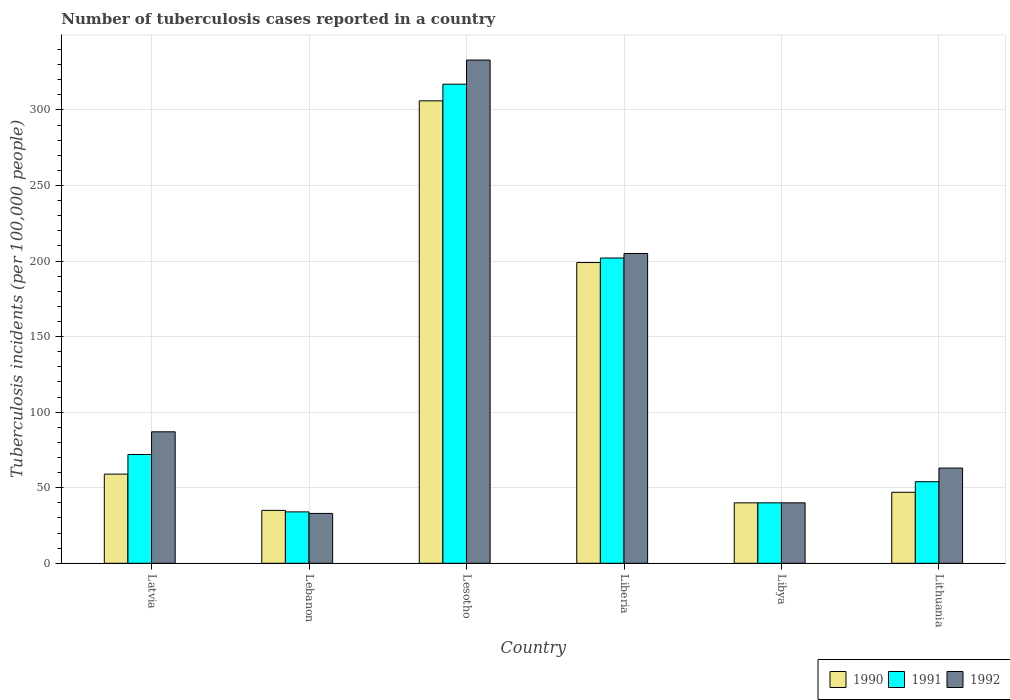How many groups of bars are there?
Your response must be concise. 6. Are the number of bars per tick equal to the number of legend labels?
Your answer should be compact. Yes. How many bars are there on the 6th tick from the right?
Provide a succinct answer. 3. What is the label of the 6th group of bars from the left?
Ensure brevity in your answer.  Lithuania. In how many cases, is the number of bars for a given country not equal to the number of legend labels?
Make the answer very short. 0. What is the number of tuberculosis cases reported in in 1990 in Lesotho?
Provide a succinct answer. 306. Across all countries, what is the maximum number of tuberculosis cases reported in in 1990?
Provide a succinct answer. 306. In which country was the number of tuberculosis cases reported in in 1991 maximum?
Ensure brevity in your answer.  Lesotho. In which country was the number of tuberculosis cases reported in in 1990 minimum?
Make the answer very short. Lebanon. What is the total number of tuberculosis cases reported in in 1990 in the graph?
Give a very brief answer. 686. What is the difference between the number of tuberculosis cases reported in in 1990 in Latvia and that in Lesotho?
Provide a short and direct response. -247. What is the difference between the number of tuberculosis cases reported in in 1991 in Liberia and the number of tuberculosis cases reported in in 1990 in Lithuania?
Provide a short and direct response. 155. What is the average number of tuberculosis cases reported in in 1990 per country?
Offer a terse response. 114.33. In how many countries, is the number of tuberculosis cases reported in in 1990 greater than 320?
Your answer should be very brief. 0. What is the ratio of the number of tuberculosis cases reported in in 1991 in Latvia to that in Lesotho?
Make the answer very short. 0.23. What is the difference between the highest and the second highest number of tuberculosis cases reported in in 1990?
Give a very brief answer. 247. What is the difference between the highest and the lowest number of tuberculosis cases reported in in 1992?
Make the answer very short. 300. In how many countries, is the number of tuberculosis cases reported in in 1990 greater than the average number of tuberculosis cases reported in in 1990 taken over all countries?
Offer a very short reply. 2. What does the 3rd bar from the left in Lithuania represents?
Keep it short and to the point. 1992. What does the 2nd bar from the right in Libya represents?
Provide a succinct answer. 1991. Is it the case that in every country, the sum of the number of tuberculosis cases reported in in 1990 and number of tuberculosis cases reported in in 1991 is greater than the number of tuberculosis cases reported in in 1992?
Make the answer very short. Yes. How many bars are there?
Keep it short and to the point. 18. Are all the bars in the graph horizontal?
Offer a terse response. No. Are the values on the major ticks of Y-axis written in scientific E-notation?
Provide a succinct answer. No. Does the graph contain any zero values?
Provide a succinct answer. No. Does the graph contain grids?
Offer a terse response. Yes. How many legend labels are there?
Offer a terse response. 3. How are the legend labels stacked?
Offer a terse response. Horizontal. What is the title of the graph?
Your answer should be compact. Number of tuberculosis cases reported in a country. What is the label or title of the Y-axis?
Make the answer very short. Tuberculosis incidents (per 100,0 people). What is the Tuberculosis incidents (per 100,000 people) in 1991 in Latvia?
Your response must be concise. 72. What is the Tuberculosis incidents (per 100,000 people) of 1991 in Lebanon?
Give a very brief answer. 34. What is the Tuberculosis incidents (per 100,000 people) in 1990 in Lesotho?
Offer a terse response. 306. What is the Tuberculosis incidents (per 100,000 people) of 1991 in Lesotho?
Give a very brief answer. 317. What is the Tuberculosis incidents (per 100,000 people) of 1992 in Lesotho?
Give a very brief answer. 333. What is the Tuberculosis incidents (per 100,000 people) in 1990 in Liberia?
Provide a succinct answer. 199. What is the Tuberculosis incidents (per 100,000 people) in 1991 in Liberia?
Provide a succinct answer. 202. What is the Tuberculosis incidents (per 100,000 people) in 1992 in Liberia?
Make the answer very short. 205. What is the Tuberculosis incidents (per 100,000 people) of 1990 in Libya?
Give a very brief answer. 40. What is the Tuberculosis incidents (per 100,000 people) of 1991 in Libya?
Ensure brevity in your answer.  40. What is the Tuberculosis incidents (per 100,000 people) in 1992 in Libya?
Ensure brevity in your answer.  40. What is the Tuberculosis incidents (per 100,000 people) of 1991 in Lithuania?
Provide a short and direct response. 54. What is the Tuberculosis incidents (per 100,000 people) of 1992 in Lithuania?
Keep it short and to the point. 63. Across all countries, what is the maximum Tuberculosis incidents (per 100,000 people) in 1990?
Provide a short and direct response. 306. Across all countries, what is the maximum Tuberculosis incidents (per 100,000 people) of 1991?
Your answer should be very brief. 317. Across all countries, what is the maximum Tuberculosis incidents (per 100,000 people) in 1992?
Your answer should be very brief. 333. What is the total Tuberculosis incidents (per 100,000 people) in 1990 in the graph?
Provide a succinct answer. 686. What is the total Tuberculosis incidents (per 100,000 people) of 1991 in the graph?
Your answer should be very brief. 719. What is the total Tuberculosis incidents (per 100,000 people) of 1992 in the graph?
Offer a very short reply. 761. What is the difference between the Tuberculosis incidents (per 100,000 people) of 1990 in Latvia and that in Lebanon?
Provide a short and direct response. 24. What is the difference between the Tuberculosis incidents (per 100,000 people) of 1991 in Latvia and that in Lebanon?
Your answer should be compact. 38. What is the difference between the Tuberculosis incidents (per 100,000 people) of 1992 in Latvia and that in Lebanon?
Provide a succinct answer. 54. What is the difference between the Tuberculosis incidents (per 100,000 people) of 1990 in Latvia and that in Lesotho?
Your answer should be very brief. -247. What is the difference between the Tuberculosis incidents (per 100,000 people) in 1991 in Latvia and that in Lesotho?
Keep it short and to the point. -245. What is the difference between the Tuberculosis incidents (per 100,000 people) in 1992 in Latvia and that in Lesotho?
Ensure brevity in your answer.  -246. What is the difference between the Tuberculosis incidents (per 100,000 people) in 1990 in Latvia and that in Liberia?
Ensure brevity in your answer.  -140. What is the difference between the Tuberculosis incidents (per 100,000 people) of 1991 in Latvia and that in Liberia?
Make the answer very short. -130. What is the difference between the Tuberculosis incidents (per 100,000 people) of 1992 in Latvia and that in Liberia?
Your response must be concise. -118. What is the difference between the Tuberculosis incidents (per 100,000 people) in 1991 in Latvia and that in Libya?
Provide a short and direct response. 32. What is the difference between the Tuberculosis incidents (per 100,000 people) in 1992 in Latvia and that in Libya?
Your response must be concise. 47. What is the difference between the Tuberculosis incidents (per 100,000 people) of 1990 in Latvia and that in Lithuania?
Provide a short and direct response. 12. What is the difference between the Tuberculosis incidents (per 100,000 people) of 1991 in Latvia and that in Lithuania?
Your answer should be compact. 18. What is the difference between the Tuberculosis incidents (per 100,000 people) in 1992 in Latvia and that in Lithuania?
Make the answer very short. 24. What is the difference between the Tuberculosis incidents (per 100,000 people) in 1990 in Lebanon and that in Lesotho?
Make the answer very short. -271. What is the difference between the Tuberculosis incidents (per 100,000 people) in 1991 in Lebanon and that in Lesotho?
Give a very brief answer. -283. What is the difference between the Tuberculosis incidents (per 100,000 people) in 1992 in Lebanon and that in Lesotho?
Offer a very short reply. -300. What is the difference between the Tuberculosis incidents (per 100,000 people) in 1990 in Lebanon and that in Liberia?
Offer a terse response. -164. What is the difference between the Tuberculosis incidents (per 100,000 people) of 1991 in Lebanon and that in Liberia?
Give a very brief answer. -168. What is the difference between the Tuberculosis incidents (per 100,000 people) in 1992 in Lebanon and that in Liberia?
Your answer should be compact. -172. What is the difference between the Tuberculosis incidents (per 100,000 people) in 1990 in Lebanon and that in Libya?
Keep it short and to the point. -5. What is the difference between the Tuberculosis incidents (per 100,000 people) in 1991 in Lebanon and that in Libya?
Keep it short and to the point. -6. What is the difference between the Tuberculosis incidents (per 100,000 people) of 1992 in Lebanon and that in Libya?
Keep it short and to the point. -7. What is the difference between the Tuberculosis incidents (per 100,000 people) in 1990 in Lebanon and that in Lithuania?
Your answer should be very brief. -12. What is the difference between the Tuberculosis incidents (per 100,000 people) in 1991 in Lebanon and that in Lithuania?
Provide a short and direct response. -20. What is the difference between the Tuberculosis incidents (per 100,000 people) in 1992 in Lebanon and that in Lithuania?
Your answer should be compact. -30. What is the difference between the Tuberculosis incidents (per 100,000 people) in 1990 in Lesotho and that in Liberia?
Offer a very short reply. 107. What is the difference between the Tuberculosis incidents (per 100,000 people) of 1991 in Lesotho and that in Liberia?
Give a very brief answer. 115. What is the difference between the Tuberculosis incidents (per 100,000 people) of 1992 in Lesotho and that in Liberia?
Ensure brevity in your answer.  128. What is the difference between the Tuberculosis incidents (per 100,000 people) in 1990 in Lesotho and that in Libya?
Ensure brevity in your answer.  266. What is the difference between the Tuberculosis incidents (per 100,000 people) in 1991 in Lesotho and that in Libya?
Your response must be concise. 277. What is the difference between the Tuberculosis incidents (per 100,000 people) of 1992 in Lesotho and that in Libya?
Your answer should be compact. 293. What is the difference between the Tuberculosis incidents (per 100,000 people) in 1990 in Lesotho and that in Lithuania?
Keep it short and to the point. 259. What is the difference between the Tuberculosis incidents (per 100,000 people) in 1991 in Lesotho and that in Lithuania?
Provide a short and direct response. 263. What is the difference between the Tuberculosis incidents (per 100,000 people) in 1992 in Lesotho and that in Lithuania?
Provide a short and direct response. 270. What is the difference between the Tuberculosis incidents (per 100,000 people) in 1990 in Liberia and that in Libya?
Ensure brevity in your answer.  159. What is the difference between the Tuberculosis incidents (per 100,000 people) of 1991 in Liberia and that in Libya?
Provide a short and direct response. 162. What is the difference between the Tuberculosis incidents (per 100,000 people) in 1992 in Liberia and that in Libya?
Offer a terse response. 165. What is the difference between the Tuberculosis incidents (per 100,000 people) in 1990 in Liberia and that in Lithuania?
Offer a very short reply. 152. What is the difference between the Tuberculosis incidents (per 100,000 people) of 1991 in Liberia and that in Lithuania?
Give a very brief answer. 148. What is the difference between the Tuberculosis incidents (per 100,000 people) of 1992 in Liberia and that in Lithuania?
Ensure brevity in your answer.  142. What is the difference between the Tuberculosis incidents (per 100,000 people) of 1990 in Libya and that in Lithuania?
Your answer should be compact. -7. What is the difference between the Tuberculosis incidents (per 100,000 people) in 1992 in Libya and that in Lithuania?
Give a very brief answer. -23. What is the difference between the Tuberculosis incidents (per 100,000 people) in 1990 in Latvia and the Tuberculosis incidents (per 100,000 people) in 1991 in Lebanon?
Offer a very short reply. 25. What is the difference between the Tuberculosis incidents (per 100,000 people) of 1990 in Latvia and the Tuberculosis incidents (per 100,000 people) of 1992 in Lebanon?
Give a very brief answer. 26. What is the difference between the Tuberculosis incidents (per 100,000 people) of 1990 in Latvia and the Tuberculosis incidents (per 100,000 people) of 1991 in Lesotho?
Provide a succinct answer. -258. What is the difference between the Tuberculosis incidents (per 100,000 people) of 1990 in Latvia and the Tuberculosis incidents (per 100,000 people) of 1992 in Lesotho?
Make the answer very short. -274. What is the difference between the Tuberculosis incidents (per 100,000 people) in 1991 in Latvia and the Tuberculosis incidents (per 100,000 people) in 1992 in Lesotho?
Your answer should be compact. -261. What is the difference between the Tuberculosis incidents (per 100,000 people) in 1990 in Latvia and the Tuberculosis incidents (per 100,000 people) in 1991 in Liberia?
Offer a terse response. -143. What is the difference between the Tuberculosis incidents (per 100,000 people) in 1990 in Latvia and the Tuberculosis incidents (per 100,000 people) in 1992 in Liberia?
Your answer should be compact. -146. What is the difference between the Tuberculosis incidents (per 100,000 people) in 1991 in Latvia and the Tuberculosis incidents (per 100,000 people) in 1992 in Liberia?
Your answer should be compact. -133. What is the difference between the Tuberculosis incidents (per 100,000 people) in 1990 in Latvia and the Tuberculosis incidents (per 100,000 people) in 1992 in Libya?
Give a very brief answer. 19. What is the difference between the Tuberculosis incidents (per 100,000 people) in 1991 in Latvia and the Tuberculosis incidents (per 100,000 people) in 1992 in Libya?
Your answer should be very brief. 32. What is the difference between the Tuberculosis incidents (per 100,000 people) of 1990 in Latvia and the Tuberculosis incidents (per 100,000 people) of 1991 in Lithuania?
Give a very brief answer. 5. What is the difference between the Tuberculosis incidents (per 100,000 people) of 1991 in Latvia and the Tuberculosis incidents (per 100,000 people) of 1992 in Lithuania?
Provide a short and direct response. 9. What is the difference between the Tuberculosis incidents (per 100,000 people) in 1990 in Lebanon and the Tuberculosis incidents (per 100,000 people) in 1991 in Lesotho?
Keep it short and to the point. -282. What is the difference between the Tuberculosis incidents (per 100,000 people) in 1990 in Lebanon and the Tuberculosis incidents (per 100,000 people) in 1992 in Lesotho?
Make the answer very short. -298. What is the difference between the Tuberculosis incidents (per 100,000 people) of 1991 in Lebanon and the Tuberculosis incidents (per 100,000 people) of 1992 in Lesotho?
Give a very brief answer. -299. What is the difference between the Tuberculosis incidents (per 100,000 people) of 1990 in Lebanon and the Tuberculosis incidents (per 100,000 people) of 1991 in Liberia?
Your answer should be very brief. -167. What is the difference between the Tuberculosis incidents (per 100,000 people) of 1990 in Lebanon and the Tuberculosis incidents (per 100,000 people) of 1992 in Liberia?
Give a very brief answer. -170. What is the difference between the Tuberculosis incidents (per 100,000 people) in 1991 in Lebanon and the Tuberculosis incidents (per 100,000 people) in 1992 in Liberia?
Your response must be concise. -171. What is the difference between the Tuberculosis incidents (per 100,000 people) of 1990 in Lebanon and the Tuberculosis incidents (per 100,000 people) of 1992 in Lithuania?
Keep it short and to the point. -28. What is the difference between the Tuberculosis incidents (per 100,000 people) in 1990 in Lesotho and the Tuberculosis incidents (per 100,000 people) in 1991 in Liberia?
Provide a succinct answer. 104. What is the difference between the Tuberculosis incidents (per 100,000 people) of 1990 in Lesotho and the Tuberculosis incidents (per 100,000 people) of 1992 in Liberia?
Your response must be concise. 101. What is the difference between the Tuberculosis incidents (per 100,000 people) of 1991 in Lesotho and the Tuberculosis incidents (per 100,000 people) of 1992 in Liberia?
Provide a succinct answer. 112. What is the difference between the Tuberculosis incidents (per 100,000 people) of 1990 in Lesotho and the Tuberculosis incidents (per 100,000 people) of 1991 in Libya?
Your response must be concise. 266. What is the difference between the Tuberculosis incidents (per 100,000 people) in 1990 in Lesotho and the Tuberculosis incidents (per 100,000 people) in 1992 in Libya?
Keep it short and to the point. 266. What is the difference between the Tuberculosis incidents (per 100,000 people) in 1991 in Lesotho and the Tuberculosis incidents (per 100,000 people) in 1992 in Libya?
Your answer should be very brief. 277. What is the difference between the Tuberculosis incidents (per 100,000 people) of 1990 in Lesotho and the Tuberculosis incidents (per 100,000 people) of 1991 in Lithuania?
Provide a short and direct response. 252. What is the difference between the Tuberculosis incidents (per 100,000 people) of 1990 in Lesotho and the Tuberculosis incidents (per 100,000 people) of 1992 in Lithuania?
Your answer should be compact. 243. What is the difference between the Tuberculosis incidents (per 100,000 people) of 1991 in Lesotho and the Tuberculosis incidents (per 100,000 people) of 1992 in Lithuania?
Keep it short and to the point. 254. What is the difference between the Tuberculosis incidents (per 100,000 people) in 1990 in Liberia and the Tuberculosis incidents (per 100,000 people) in 1991 in Libya?
Make the answer very short. 159. What is the difference between the Tuberculosis incidents (per 100,000 people) in 1990 in Liberia and the Tuberculosis incidents (per 100,000 people) in 1992 in Libya?
Make the answer very short. 159. What is the difference between the Tuberculosis incidents (per 100,000 people) of 1991 in Liberia and the Tuberculosis incidents (per 100,000 people) of 1992 in Libya?
Offer a terse response. 162. What is the difference between the Tuberculosis incidents (per 100,000 people) of 1990 in Liberia and the Tuberculosis incidents (per 100,000 people) of 1991 in Lithuania?
Your answer should be compact. 145. What is the difference between the Tuberculosis incidents (per 100,000 people) in 1990 in Liberia and the Tuberculosis incidents (per 100,000 people) in 1992 in Lithuania?
Ensure brevity in your answer.  136. What is the difference between the Tuberculosis incidents (per 100,000 people) in 1991 in Liberia and the Tuberculosis incidents (per 100,000 people) in 1992 in Lithuania?
Offer a terse response. 139. What is the average Tuberculosis incidents (per 100,000 people) of 1990 per country?
Ensure brevity in your answer.  114.33. What is the average Tuberculosis incidents (per 100,000 people) in 1991 per country?
Offer a terse response. 119.83. What is the average Tuberculosis incidents (per 100,000 people) in 1992 per country?
Offer a terse response. 126.83. What is the difference between the Tuberculosis incidents (per 100,000 people) in 1990 and Tuberculosis incidents (per 100,000 people) in 1992 in Latvia?
Ensure brevity in your answer.  -28. What is the difference between the Tuberculosis incidents (per 100,000 people) of 1991 and Tuberculosis incidents (per 100,000 people) of 1992 in Latvia?
Give a very brief answer. -15. What is the difference between the Tuberculosis incidents (per 100,000 people) of 1990 and Tuberculosis incidents (per 100,000 people) of 1992 in Lebanon?
Your answer should be very brief. 2. What is the difference between the Tuberculosis incidents (per 100,000 people) in 1990 and Tuberculosis incidents (per 100,000 people) in 1991 in Lesotho?
Ensure brevity in your answer.  -11. What is the difference between the Tuberculosis incidents (per 100,000 people) of 1990 and Tuberculosis incidents (per 100,000 people) of 1992 in Lesotho?
Provide a succinct answer. -27. What is the difference between the Tuberculosis incidents (per 100,000 people) in 1991 and Tuberculosis incidents (per 100,000 people) in 1992 in Lesotho?
Provide a short and direct response. -16. What is the difference between the Tuberculosis incidents (per 100,000 people) in 1990 and Tuberculosis incidents (per 100,000 people) in 1991 in Liberia?
Keep it short and to the point. -3. What is the difference between the Tuberculosis incidents (per 100,000 people) in 1990 and Tuberculosis incidents (per 100,000 people) in 1992 in Liberia?
Provide a short and direct response. -6. What is the difference between the Tuberculosis incidents (per 100,000 people) of 1990 and Tuberculosis incidents (per 100,000 people) of 1991 in Libya?
Offer a terse response. 0. What is the difference between the Tuberculosis incidents (per 100,000 people) of 1991 and Tuberculosis incidents (per 100,000 people) of 1992 in Libya?
Provide a short and direct response. 0. What is the difference between the Tuberculosis incidents (per 100,000 people) in 1990 and Tuberculosis incidents (per 100,000 people) in 1991 in Lithuania?
Make the answer very short. -7. What is the difference between the Tuberculosis incidents (per 100,000 people) of 1991 and Tuberculosis incidents (per 100,000 people) of 1992 in Lithuania?
Offer a terse response. -9. What is the ratio of the Tuberculosis incidents (per 100,000 people) in 1990 in Latvia to that in Lebanon?
Your answer should be very brief. 1.69. What is the ratio of the Tuberculosis incidents (per 100,000 people) of 1991 in Latvia to that in Lebanon?
Provide a short and direct response. 2.12. What is the ratio of the Tuberculosis incidents (per 100,000 people) of 1992 in Latvia to that in Lebanon?
Provide a short and direct response. 2.64. What is the ratio of the Tuberculosis incidents (per 100,000 people) of 1990 in Latvia to that in Lesotho?
Give a very brief answer. 0.19. What is the ratio of the Tuberculosis incidents (per 100,000 people) in 1991 in Latvia to that in Lesotho?
Provide a short and direct response. 0.23. What is the ratio of the Tuberculosis incidents (per 100,000 people) of 1992 in Latvia to that in Lesotho?
Offer a very short reply. 0.26. What is the ratio of the Tuberculosis incidents (per 100,000 people) of 1990 in Latvia to that in Liberia?
Make the answer very short. 0.3. What is the ratio of the Tuberculosis incidents (per 100,000 people) of 1991 in Latvia to that in Liberia?
Keep it short and to the point. 0.36. What is the ratio of the Tuberculosis incidents (per 100,000 people) in 1992 in Latvia to that in Liberia?
Provide a succinct answer. 0.42. What is the ratio of the Tuberculosis incidents (per 100,000 people) in 1990 in Latvia to that in Libya?
Your response must be concise. 1.48. What is the ratio of the Tuberculosis incidents (per 100,000 people) of 1991 in Latvia to that in Libya?
Make the answer very short. 1.8. What is the ratio of the Tuberculosis incidents (per 100,000 people) of 1992 in Latvia to that in Libya?
Keep it short and to the point. 2.17. What is the ratio of the Tuberculosis incidents (per 100,000 people) of 1990 in Latvia to that in Lithuania?
Make the answer very short. 1.26. What is the ratio of the Tuberculosis incidents (per 100,000 people) in 1991 in Latvia to that in Lithuania?
Provide a short and direct response. 1.33. What is the ratio of the Tuberculosis incidents (per 100,000 people) in 1992 in Latvia to that in Lithuania?
Provide a succinct answer. 1.38. What is the ratio of the Tuberculosis incidents (per 100,000 people) in 1990 in Lebanon to that in Lesotho?
Give a very brief answer. 0.11. What is the ratio of the Tuberculosis incidents (per 100,000 people) in 1991 in Lebanon to that in Lesotho?
Your answer should be compact. 0.11. What is the ratio of the Tuberculosis incidents (per 100,000 people) of 1992 in Lebanon to that in Lesotho?
Make the answer very short. 0.1. What is the ratio of the Tuberculosis incidents (per 100,000 people) in 1990 in Lebanon to that in Liberia?
Provide a short and direct response. 0.18. What is the ratio of the Tuberculosis incidents (per 100,000 people) of 1991 in Lebanon to that in Liberia?
Provide a short and direct response. 0.17. What is the ratio of the Tuberculosis incidents (per 100,000 people) of 1992 in Lebanon to that in Liberia?
Your response must be concise. 0.16. What is the ratio of the Tuberculosis incidents (per 100,000 people) in 1990 in Lebanon to that in Libya?
Your response must be concise. 0.88. What is the ratio of the Tuberculosis incidents (per 100,000 people) in 1992 in Lebanon to that in Libya?
Offer a terse response. 0.82. What is the ratio of the Tuberculosis incidents (per 100,000 people) in 1990 in Lebanon to that in Lithuania?
Offer a very short reply. 0.74. What is the ratio of the Tuberculosis incidents (per 100,000 people) of 1991 in Lebanon to that in Lithuania?
Your answer should be compact. 0.63. What is the ratio of the Tuberculosis incidents (per 100,000 people) of 1992 in Lebanon to that in Lithuania?
Give a very brief answer. 0.52. What is the ratio of the Tuberculosis incidents (per 100,000 people) of 1990 in Lesotho to that in Liberia?
Your answer should be very brief. 1.54. What is the ratio of the Tuberculosis incidents (per 100,000 people) in 1991 in Lesotho to that in Liberia?
Offer a terse response. 1.57. What is the ratio of the Tuberculosis incidents (per 100,000 people) in 1992 in Lesotho to that in Liberia?
Your response must be concise. 1.62. What is the ratio of the Tuberculosis incidents (per 100,000 people) of 1990 in Lesotho to that in Libya?
Your response must be concise. 7.65. What is the ratio of the Tuberculosis incidents (per 100,000 people) of 1991 in Lesotho to that in Libya?
Give a very brief answer. 7.92. What is the ratio of the Tuberculosis incidents (per 100,000 people) of 1992 in Lesotho to that in Libya?
Give a very brief answer. 8.32. What is the ratio of the Tuberculosis incidents (per 100,000 people) of 1990 in Lesotho to that in Lithuania?
Your answer should be very brief. 6.51. What is the ratio of the Tuberculosis incidents (per 100,000 people) of 1991 in Lesotho to that in Lithuania?
Your answer should be compact. 5.87. What is the ratio of the Tuberculosis incidents (per 100,000 people) in 1992 in Lesotho to that in Lithuania?
Provide a succinct answer. 5.29. What is the ratio of the Tuberculosis incidents (per 100,000 people) in 1990 in Liberia to that in Libya?
Offer a very short reply. 4.97. What is the ratio of the Tuberculosis incidents (per 100,000 people) in 1991 in Liberia to that in Libya?
Keep it short and to the point. 5.05. What is the ratio of the Tuberculosis incidents (per 100,000 people) of 1992 in Liberia to that in Libya?
Offer a very short reply. 5.12. What is the ratio of the Tuberculosis incidents (per 100,000 people) in 1990 in Liberia to that in Lithuania?
Provide a short and direct response. 4.23. What is the ratio of the Tuberculosis incidents (per 100,000 people) of 1991 in Liberia to that in Lithuania?
Your response must be concise. 3.74. What is the ratio of the Tuberculosis incidents (per 100,000 people) of 1992 in Liberia to that in Lithuania?
Your response must be concise. 3.25. What is the ratio of the Tuberculosis incidents (per 100,000 people) of 1990 in Libya to that in Lithuania?
Offer a very short reply. 0.85. What is the ratio of the Tuberculosis incidents (per 100,000 people) of 1991 in Libya to that in Lithuania?
Make the answer very short. 0.74. What is the ratio of the Tuberculosis incidents (per 100,000 people) in 1992 in Libya to that in Lithuania?
Your answer should be compact. 0.63. What is the difference between the highest and the second highest Tuberculosis incidents (per 100,000 people) in 1990?
Give a very brief answer. 107. What is the difference between the highest and the second highest Tuberculosis incidents (per 100,000 people) of 1991?
Provide a succinct answer. 115. What is the difference between the highest and the second highest Tuberculosis incidents (per 100,000 people) of 1992?
Give a very brief answer. 128. What is the difference between the highest and the lowest Tuberculosis incidents (per 100,000 people) in 1990?
Provide a short and direct response. 271. What is the difference between the highest and the lowest Tuberculosis incidents (per 100,000 people) of 1991?
Offer a very short reply. 283. What is the difference between the highest and the lowest Tuberculosis incidents (per 100,000 people) in 1992?
Provide a succinct answer. 300. 